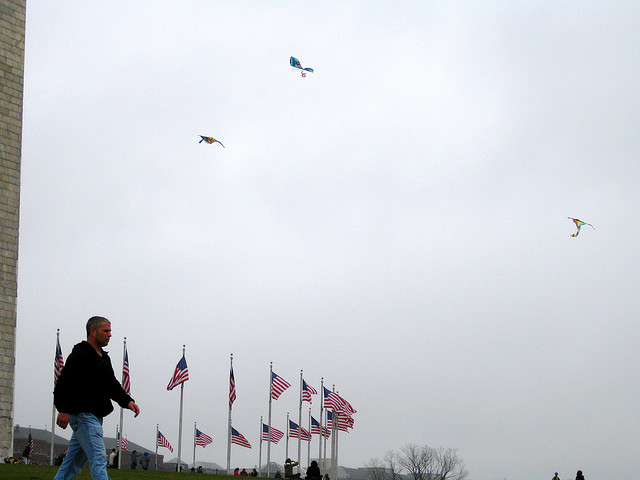<image>Which is the older item? It is ambiguous to determine which item is older. It can be either the flag or the man. Where is this located? The location is unknown. But it may be in the United States, possibly in Washington DC or Detroit. How many stars on the flag are hidden? It is unclear how many stars on the flag are hidden. What state flag is in the scene? There is no specific state flag in the scene. It can be the United States or American flag. How many stars on the flag are hidden? It is unclear how many stars on the flag are hidden. Which is the older item? The older item is not definite. It can be either the flag or the person. Where is this located? I don't know where this is located. It can be in United States, Washington DC, or outside. What state flag is in the scene? I don't know what state flag is in the scene. It can be either the United States flag or the American flag. 